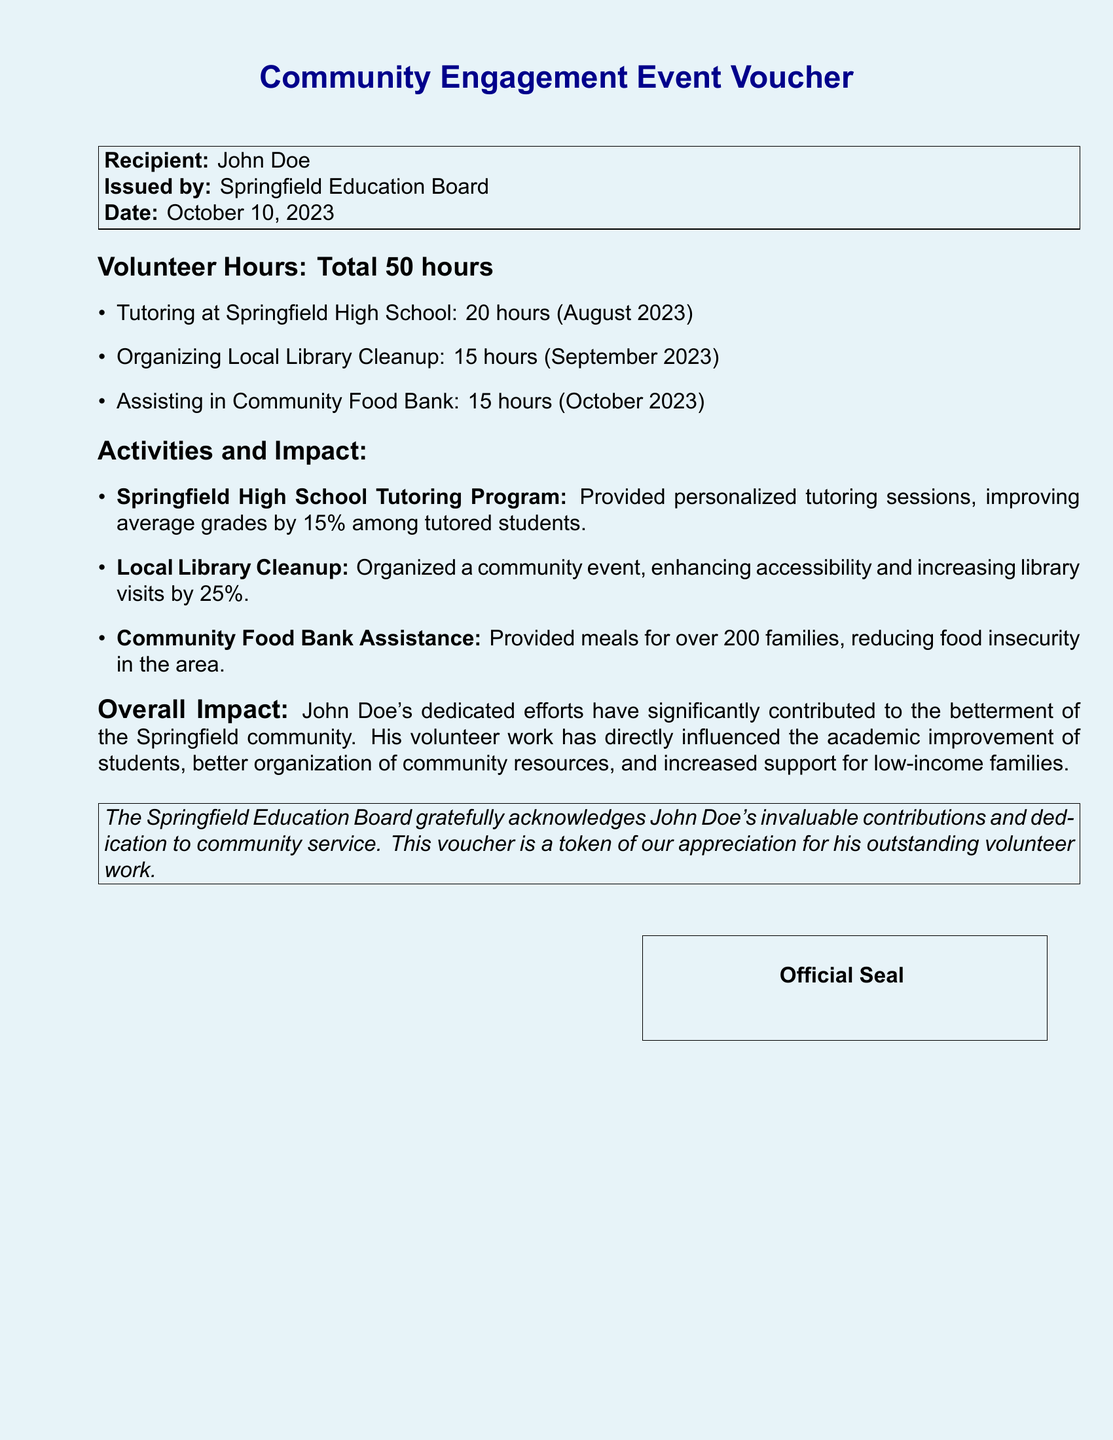What is the recipient's name? The recipient's name is listed at the top of the document.
Answer: John Doe How many total volunteer hours are credited? The total volunteer hours are mentioned in the section outlining volunteer hours in the document.
Answer: 50 hours What activity contributed 20 hours of volunteering? The document specifies the activities and their corresponding hours.
Answer: Tutoring at Springfield High School What was the percentage increase in average grades due to tutoring? The impact of the tutoring program includes a specific percentage related to grades.
Answer: 15% How many families received meals from the food bank assistance? The document mentions the number of families impacted by the community food bank assistance.
Answer: Over 200 families What was the date the voucher was issued? The issuance date of the voucher is clearly stated in the document.
Answer: October 10, 2023 Which organization issued the voucher? The issuer of the voucher is mentioned prominently in the document.
Answer: Springfield Education Board What was the impact of the local library cleanup on library visits? The document describes the outcome of the library cleanup in terms of increased visitor numbers.
Answer: 25% What is stated as John Doe's overall impact on the community? The overall impact section summarizes his contributions to the community.
Answer: Betterment of the Springfield community 